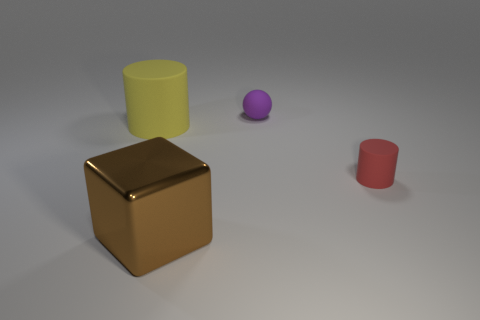What color is the matte cylinder that is on the right side of the yellow object?
Provide a short and direct response. Red. The yellow matte cylinder is what size?
Provide a succinct answer. Large. Does the metal block have the same size as the rubber cylinder left of the tiny red matte object?
Make the answer very short. Yes. There is a matte cylinder that is in front of the cylinder that is behind the object that is right of the purple rubber thing; what color is it?
Ensure brevity in your answer.  Red. Is the thing that is behind the yellow rubber cylinder made of the same material as the big yellow thing?
Provide a short and direct response. Yes. How many other things are the same material as the large brown object?
Ensure brevity in your answer.  0. What is the material of the other thing that is the same size as the yellow rubber object?
Provide a short and direct response. Metal. Does the matte thing that is behind the yellow rubber cylinder have the same shape as the big object in front of the red cylinder?
Ensure brevity in your answer.  No. There is a brown shiny thing that is the same size as the yellow cylinder; what shape is it?
Your answer should be compact. Cube. Does the big thing in front of the yellow cylinder have the same material as the cylinder that is to the left of the big brown cube?
Your answer should be compact. No. 